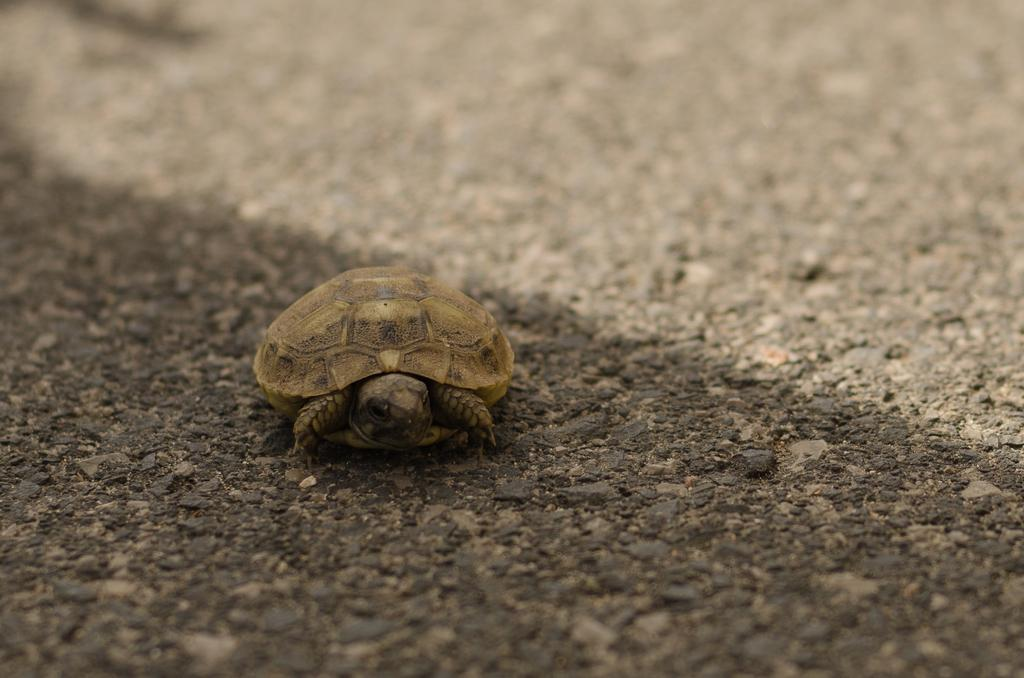What type of animal is in the image? There is a small turtle in the image. Where is the turtle located in the image? The turtle is on the ground. What type of power source is visible in the image? There is no power source visible in the image; it features a small turtle on the ground. What time of day is depicted in the image? The time of day is not specified in the image, as it only features a small turtle on the ground. 